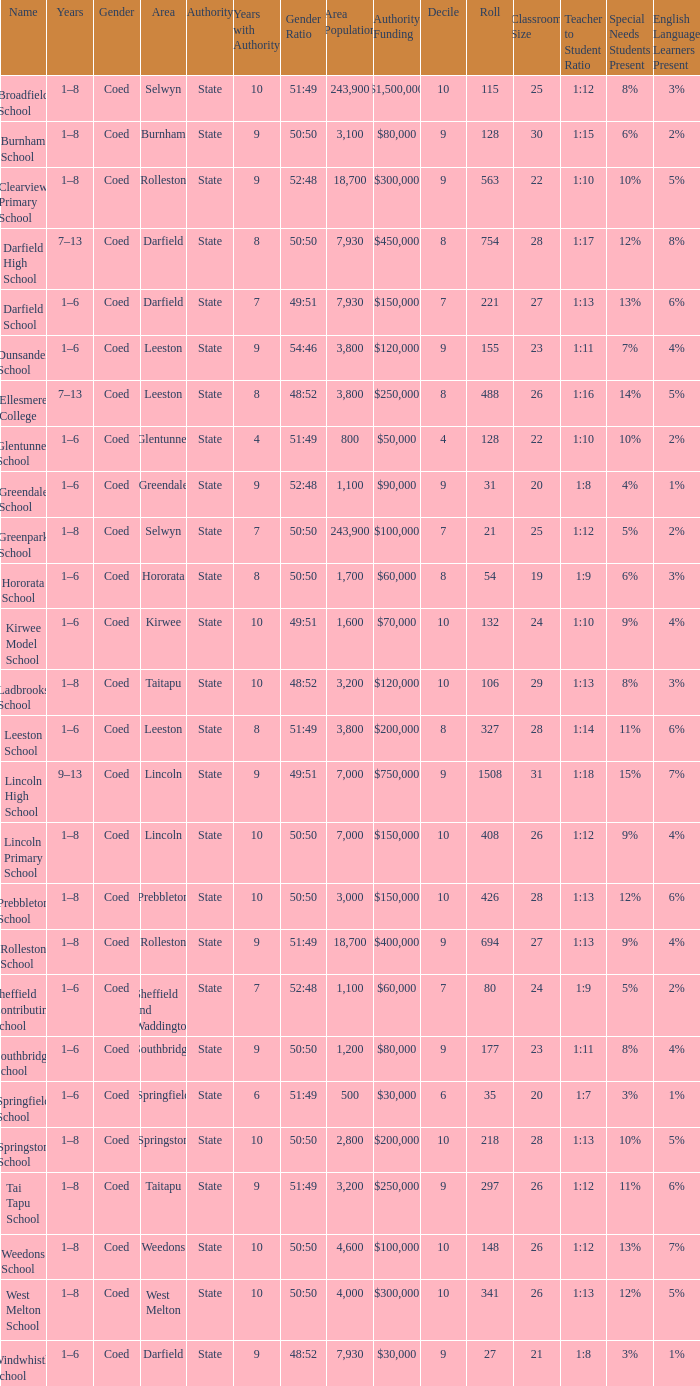What is the total of the roll with a Decile of 8, and an Area of hororata? 54.0. 